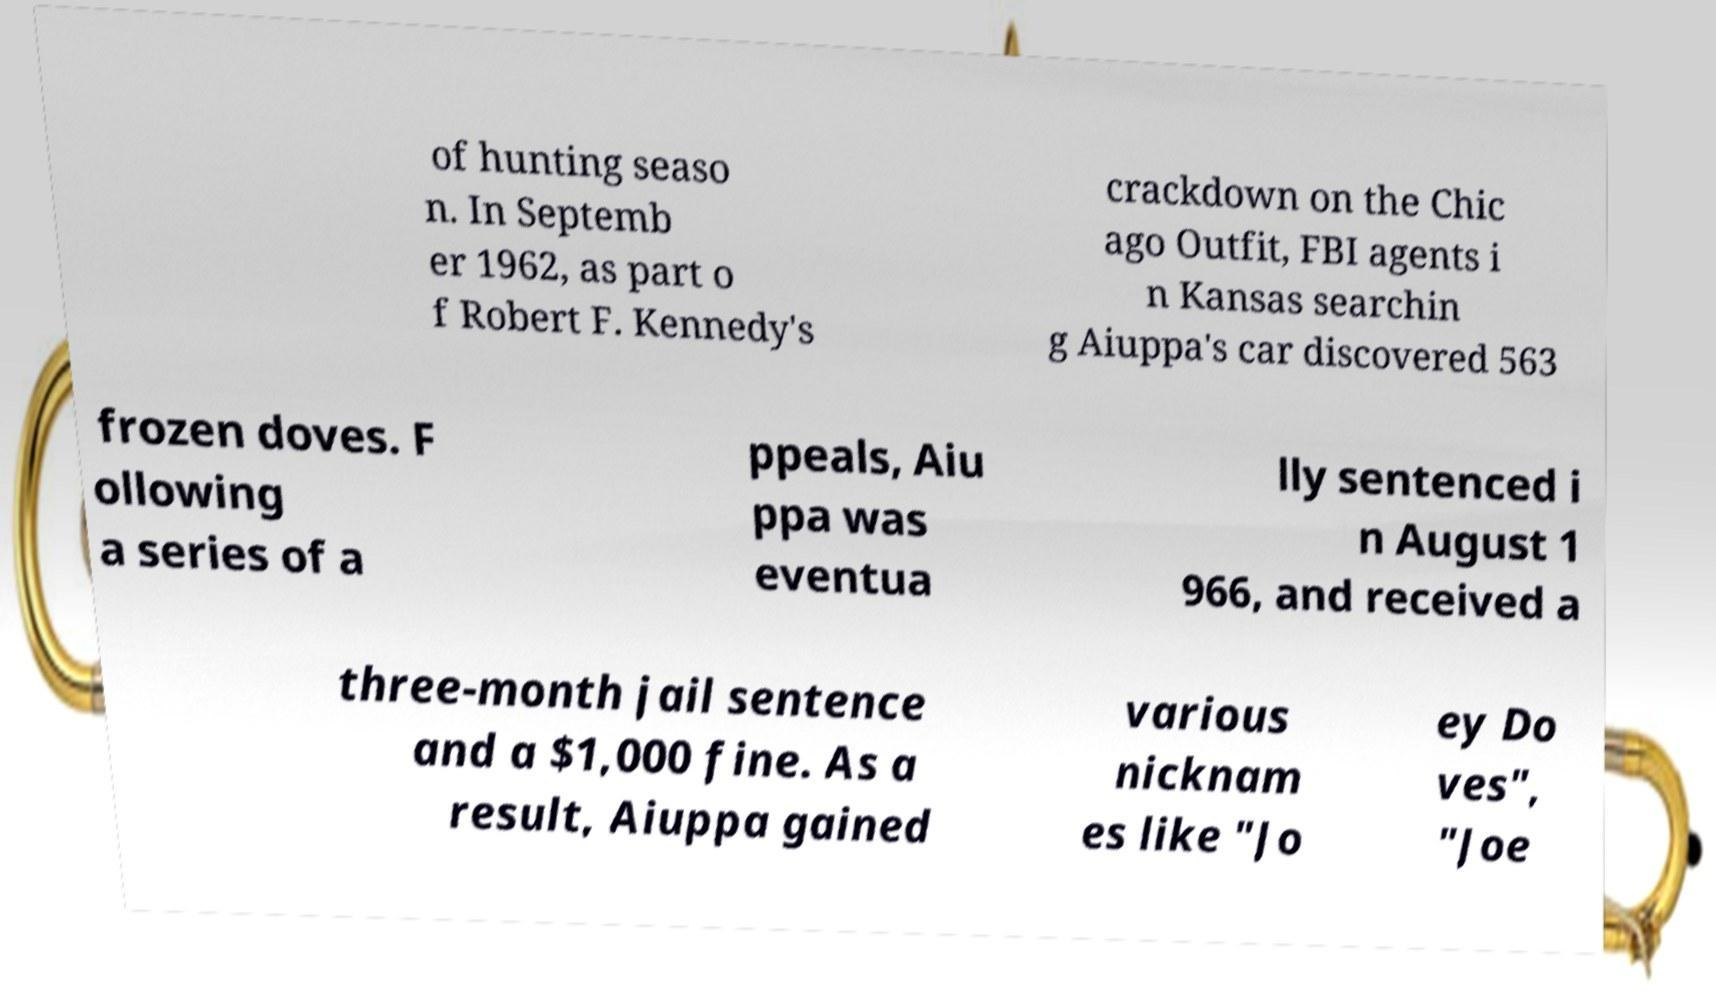Could you assist in decoding the text presented in this image and type it out clearly? of hunting seaso n. In Septemb er 1962, as part o f Robert F. Kennedy's crackdown on the Chic ago Outfit, FBI agents i n Kansas searchin g Aiuppa's car discovered 563 frozen doves. F ollowing a series of a ppeals, Aiu ppa was eventua lly sentenced i n August 1 966, and received a three-month jail sentence and a $1,000 fine. As a result, Aiuppa gained various nicknam es like "Jo ey Do ves", "Joe 